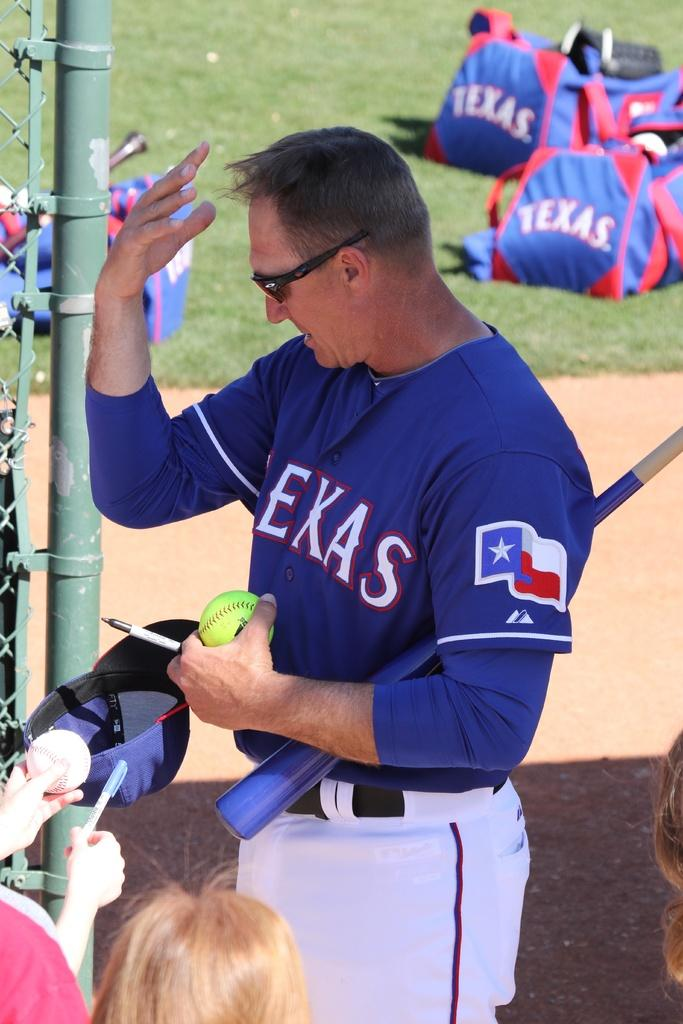<image>
Provide a brief description of the given image. The texas player is fixing his hair while holding the ball. 